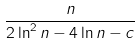<formula> <loc_0><loc_0><loc_500><loc_500>\frac { n } { 2 \ln ^ { 2 } n - 4 \ln n - c }</formula> 